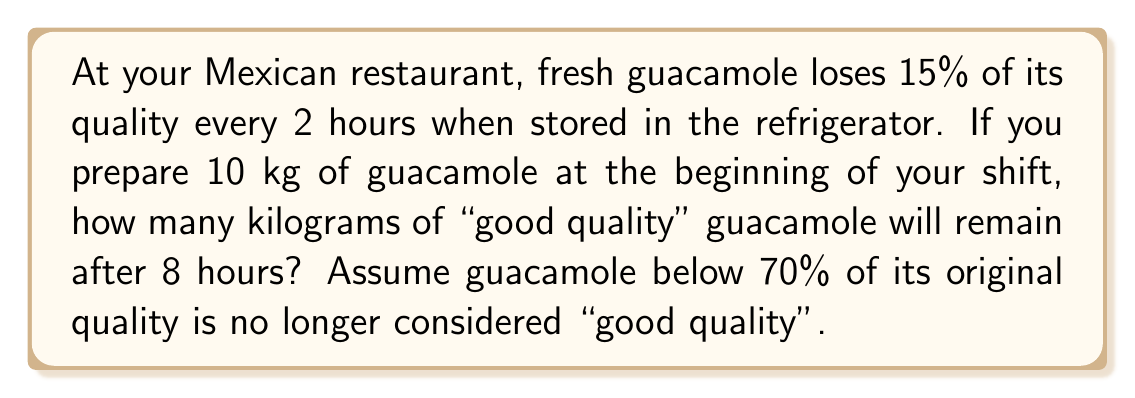Could you help me with this problem? Let's approach this step-by-step:

1) First, we need to determine the decay factor for every 2-hour period:
   Decay factor = 1 - 0.15 = 0.85

2) Now, we can set up an exponential decay formula:
   $A = A_0 \cdot (0.85)^{t/2}$
   Where $A$ is the amount after time $t$, $A_0$ is the initial amount, and $t$ is time in hours.

3) We want to find the quality after 8 hours:
   $A = 10 \cdot (0.85)^{8/2} = 10 \cdot (0.85)^4$

4) Calculate this:
   $A = 10 \cdot 0.5220 = 5.220$ kg

5) However, we need to check if this is still considered "good quality":
   $5.220 / 10 = 0.522$ or 52.2%

6) Since 52.2% < 70%, this guacamole is no longer considered "good quality".

Therefore, after 8 hours, there will be 0 kg of "good quality" guacamole remaining.
Answer: 0 kg 